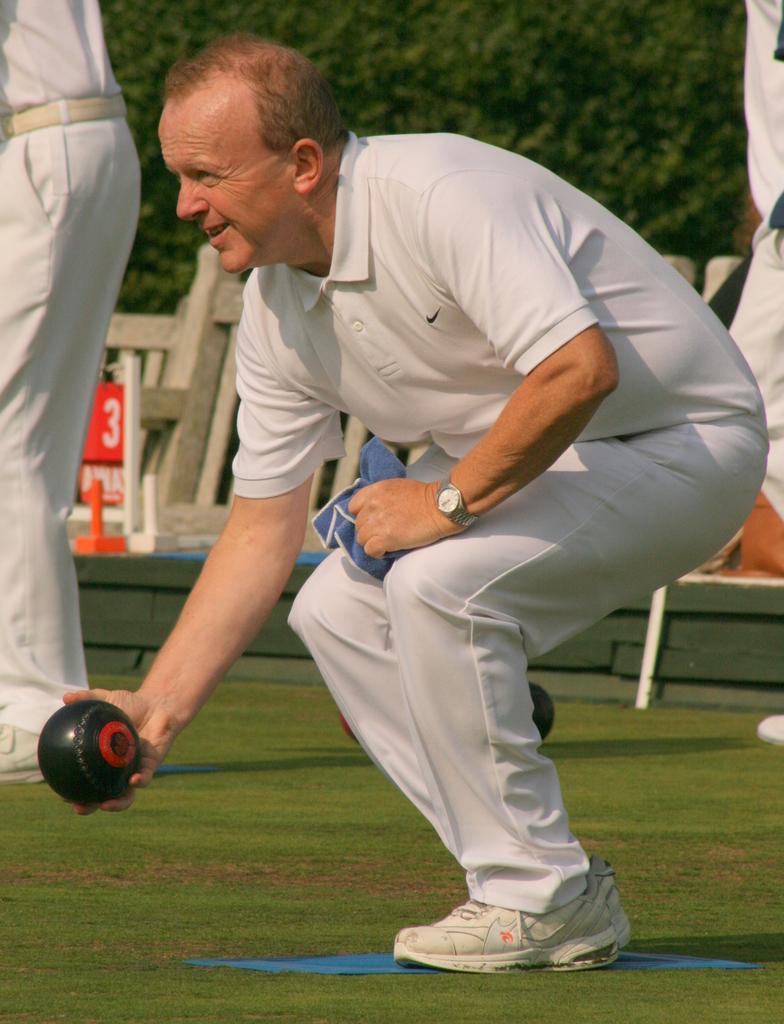Could you give a brief overview of what you see in this image? In this image I can see a person holding a ball and the ball is in black color and the person is wearing white color dress. Background I can see few other persons standing, I can also see a bench and trees in green color. 